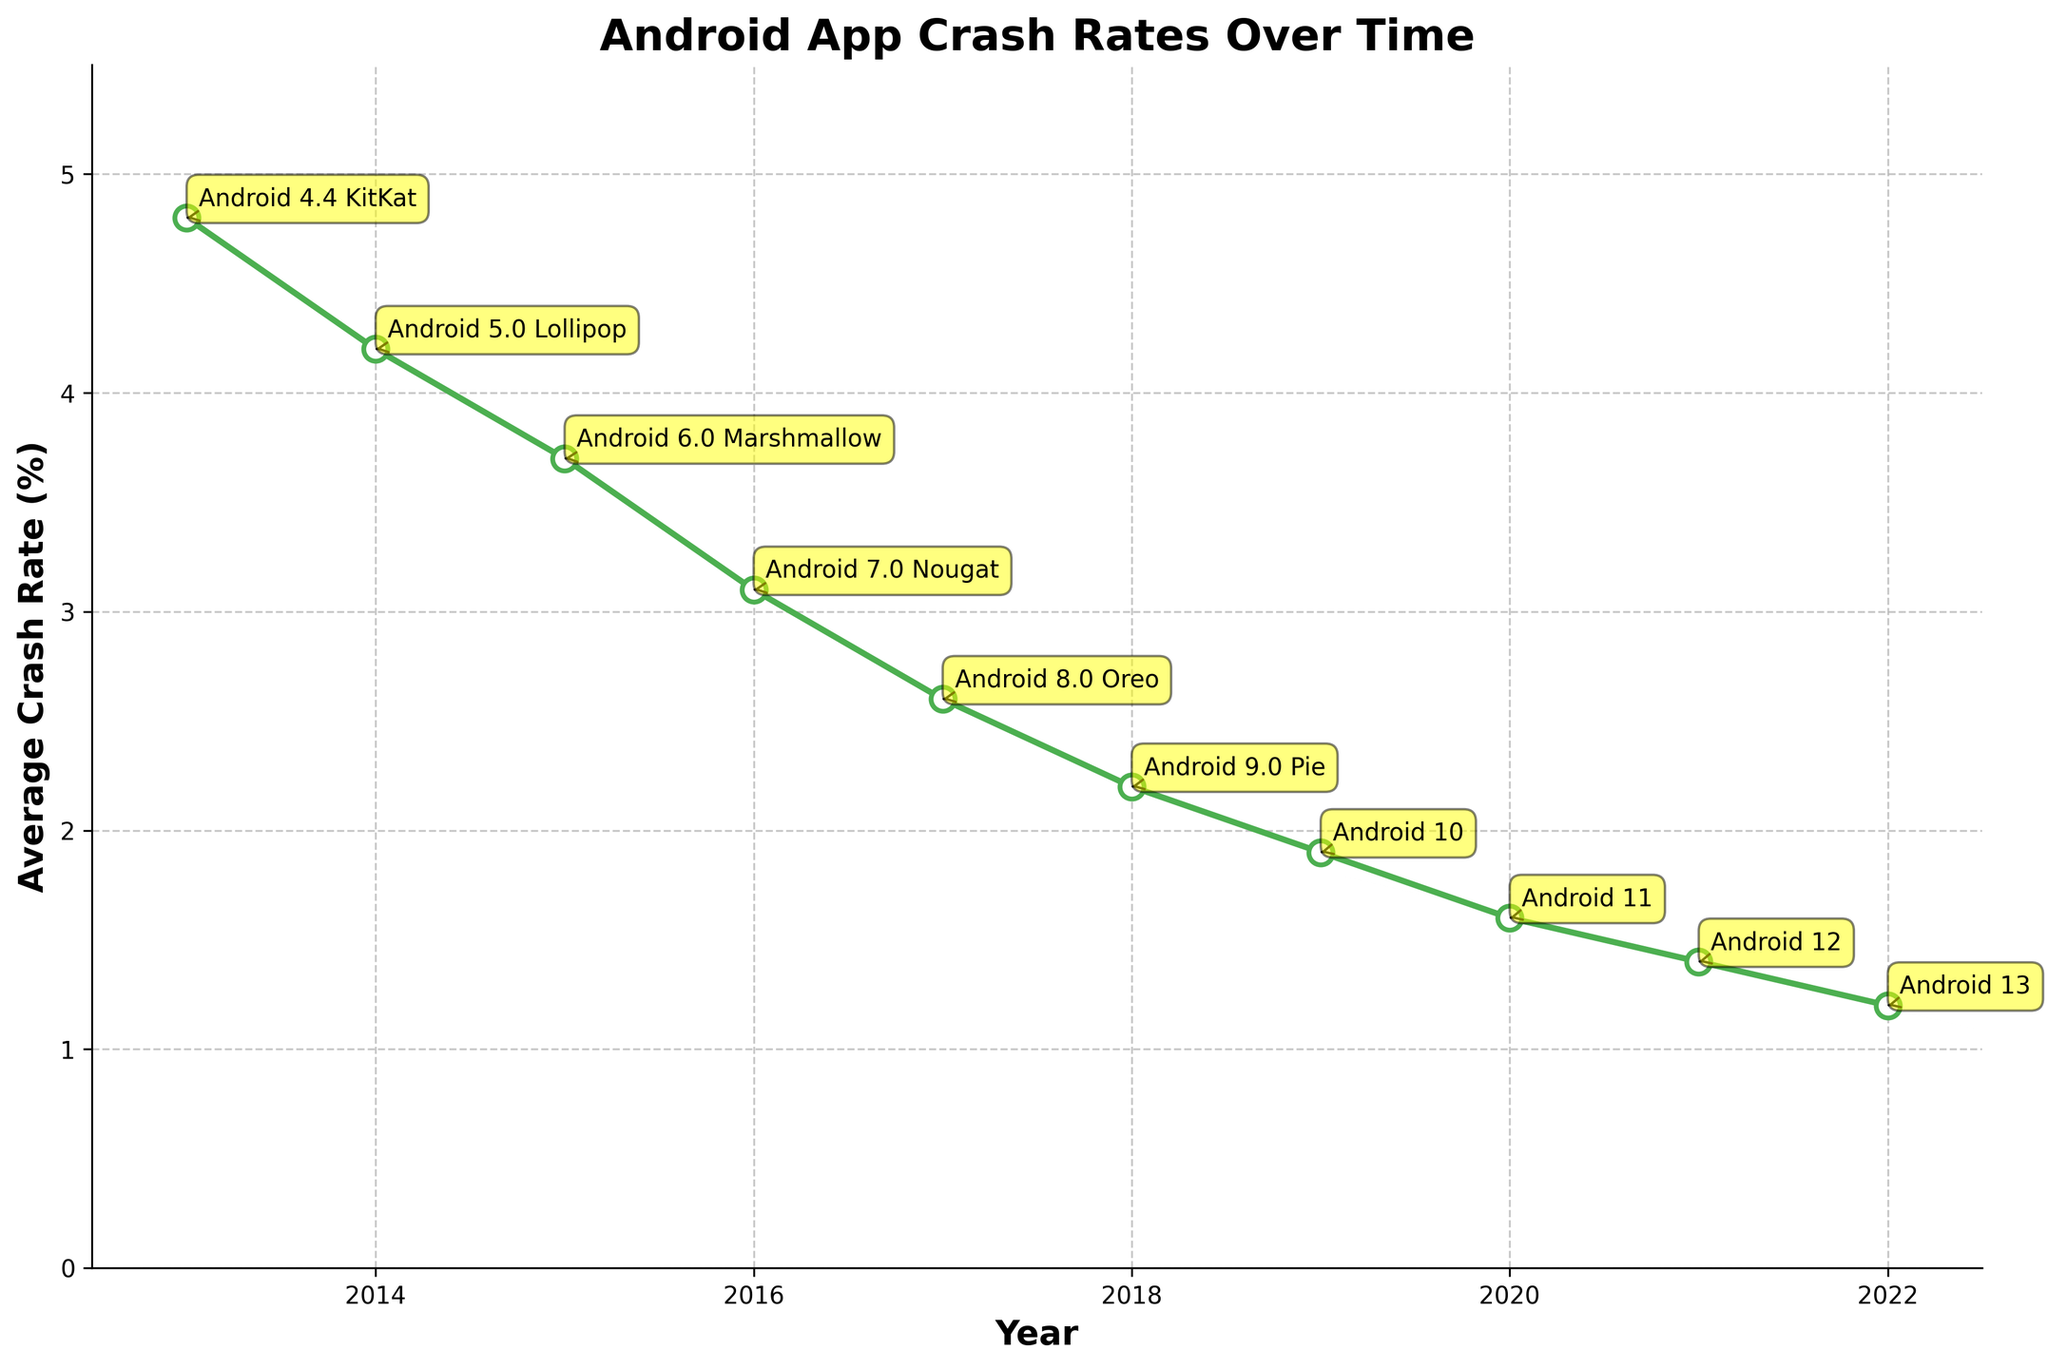What is the average crash rate for Android 10? To find the average crash rate for Android 10, look for the year 2019 on the x-axis, and then locate the corresponding point on the y-axis. The point is labeled and annotated with 'Android 10'. Check the y-axis value for this annotation.
Answer: 1.9% Is the crash rate for Android 9.0 Pie higher than that of Android 8.0 Oreo? Look for the years corresponding to Android 9.0 Pie (2018) and Android 8.0 Oreo (2017). Compare their respective crash rates on the y-axis. Android 9.0 Pie has a crash rate of 2.2%, while Android 8.0 Oreo has a crash rate of 2.6%.
Answer: No Which Android version shows the steepest decline in crash rates from its predecessor? Look for the two consecutive years with the largest vertical distance between the crash rates. This is between Android 8.0 Oreo (2.6% in 2017) and Android 7.0 Nougat (3.1% in 2016), a decline of 0.5%.
Answer: Android 8.0 Oreo What was the difference in crash rates between the year 2015 (Android 6.0 Marshmallow) and the year 2020 (Android 11)? Identify the crash rates for the years 2015 and 2020. Android 6.0 Marshmallow in 2015 had a rate of 3.7%, and Android 11 in 2020 had a rate of 1.6%. The difference is calculated as 3.7% - 1.6%.
Answer: 2.1% By how much did the crash rate improve from Android 4.4 KitKat to Android 12? Locate the crash rates for Android 4.4 KitKat (2013) and Android 12 (2021). Android 4.4 KitKat had a crash rate of 4.8%, and Android 12 had 1.4%. The improvement is 4.8% - 1.4%.
Answer: 3.4% Which Android version had a crash rate of 1.2%? Look along the y-axis for the crash rate of 1.2% and trace it back to the corresponding year and annotation. The highlighted version is Android 13 (2022).
Answer: Android 13 In which year did the Android version have a crash rate of above 4%? Check all the points on the plot with crash rates above 4% and identify the corresponding years. Only Android 4.4 KitKat in 2013 had a crash rate above 4%, with 4.8%.
Answer: 2013 How many Android versions had an average crash rate below 2%? Count the number of points on the graph with crash rates below 2%. These are Android 11 (2020 with 1.6%), Android 12 (2021 with 1.4%), and Android 13 (2022 with 1.2%). There are three such versions.
Answer: 3 